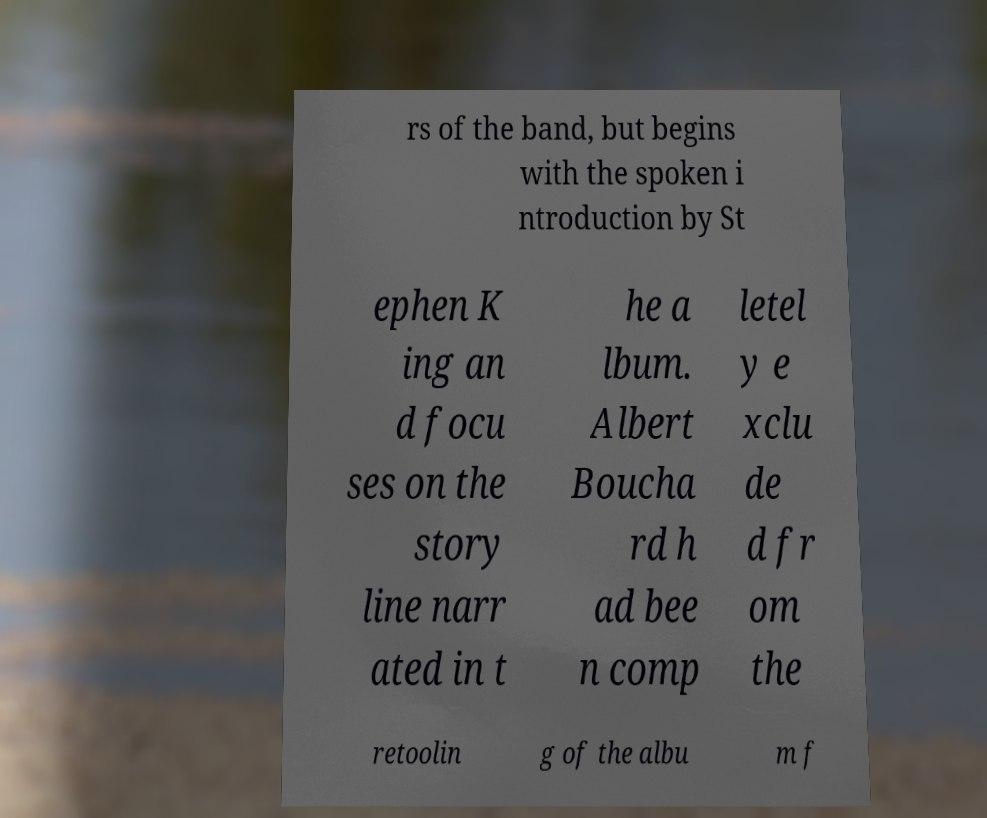Please read and relay the text visible in this image. What does it say? rs of the band, but begins with the spoken i ntroduction by St ephen K ing an d focu ses on the story line narr ated in t he a lbum. Albert Boucha rd h ad bee n comp letel y e xclu de d fr om the retoolin g of the albu m f 